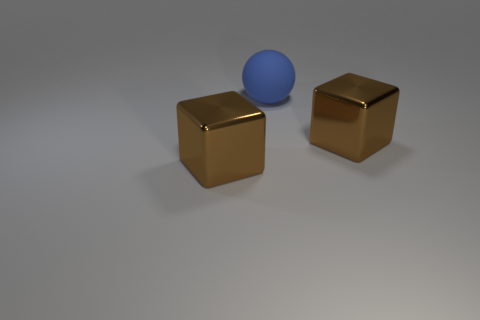Add 1 matte things. How many objects exist? 4 Subtract all spheres. How many objects are left? 2 Add 1 brown things. How many brown things exist? 3 Subtract 0 yellow cylinders. How many objects are left? 3 Subtract all blue objects. Subtract all blue rubber balls. How many objects are left? 1 Add 1 big brown metal blocks. How many big brown metal blocks are left? 3 